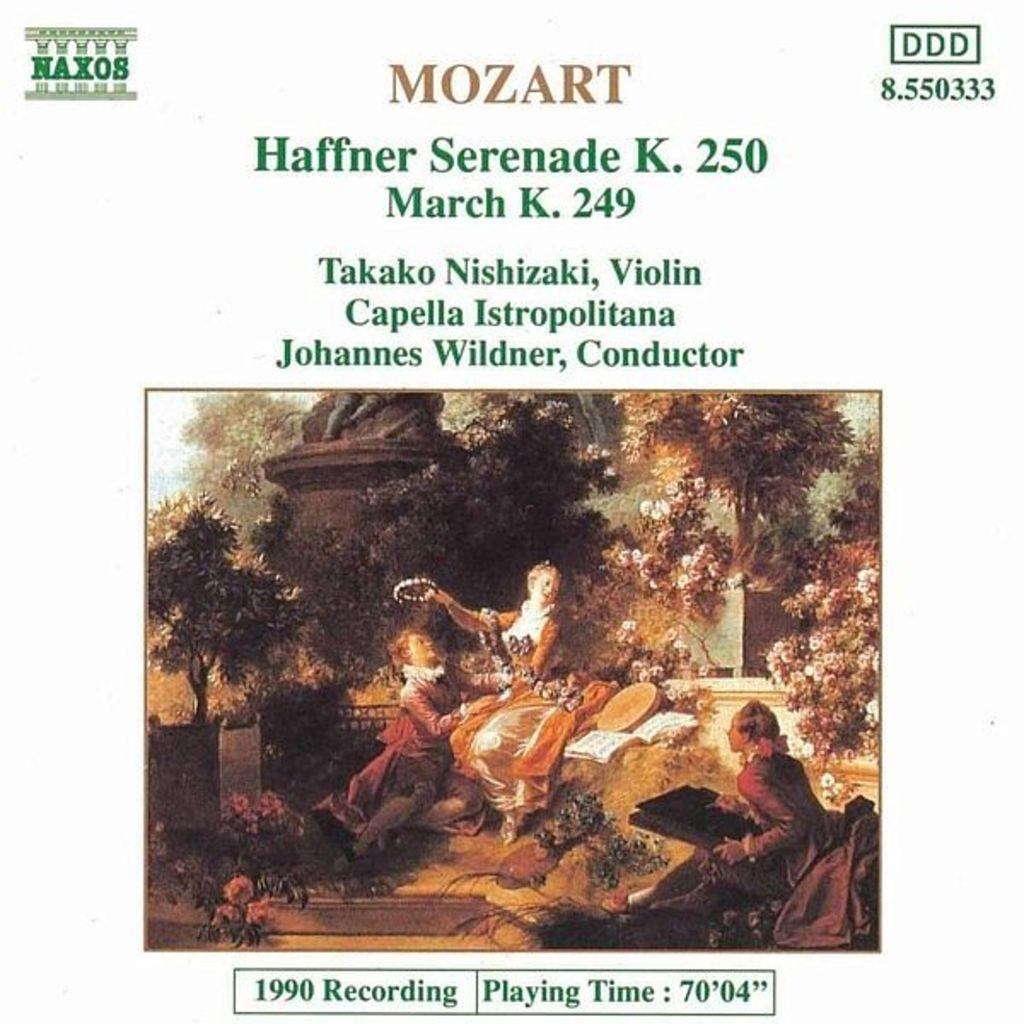What is featured on the poster in the image? The poster contains an image of a few people. What type of background can be seen behind the poster? There is a wall visible in the image behind the poster. What type of natural elements are present in the image? There are trees in the image. What type of text is present on the poster? There is edited text in the image. Where is the oven located in the image? There is no oven present in the image. Can you see any animals in the image? The image does not depict a zoo or any animals; it features a poster with an image of people and text. 